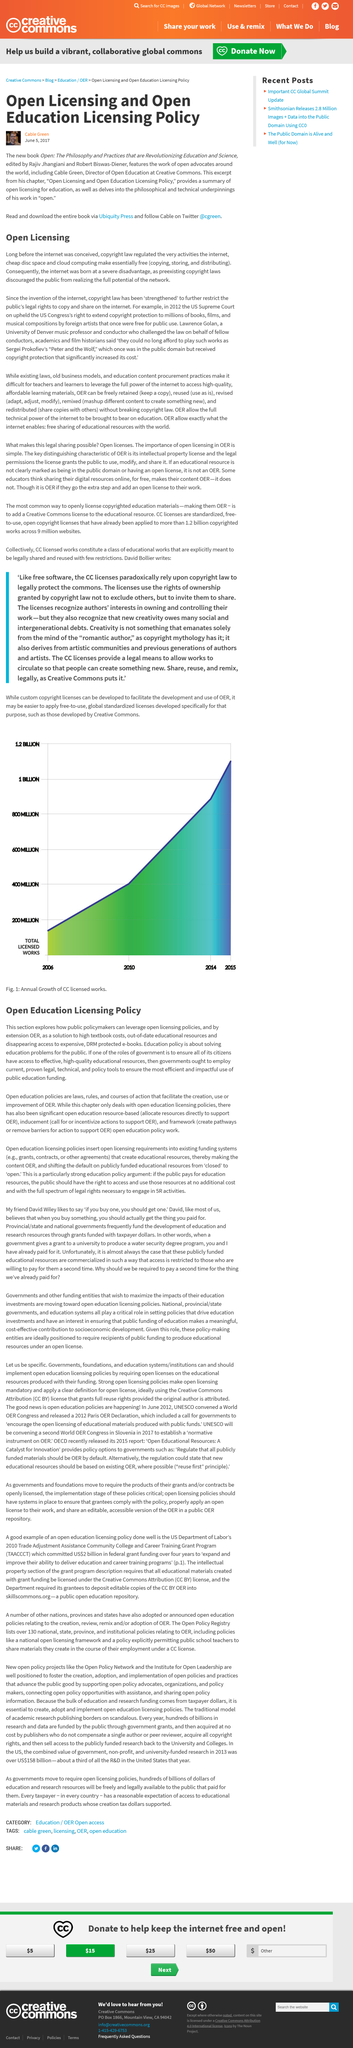Indicate a few pertinent items in this graphic. Copyright laws regulate copying and storing. Open licensing policies can be leveraged by public policymakers. Education policy is the solution to addressing the issues in the education system. I declare that the book edited by Rajiv Jhangiani and Robert Biswas-Diener, titled [insert title], is revolutionizing education and science through its philosophy and practices. Green Cable, also known as Green Cable, is an advocate for open licensing and open education. Yes. 